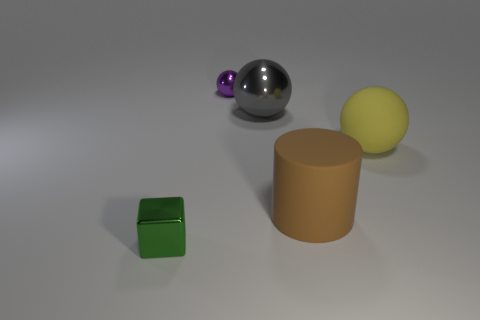How many other objects are the same material as the small purple ball?
Offer a very short reply. 2. How many small things are purple metal things or brown cylinders?
Make the answer very short. 1. Are there an equal number of large yellow rubber objects that are behind the gray metallic object and big things?
Your answer should be compact. No. There is a tiny metallic object that is in front of the purple ball; are there any gray things that are on the right side of it?
Give a very brief answer. Yes. What number of other things are there of the same color as the cube?
Your answer should be very brief. 0. What color is the big metallic ball?
Keep it short and to the point. Gray. There is a sphere that is both in front of the purple object and on the left side of the cylinder; what is its size?
Offer a very short reply. Large. How many objects are metallic objects that are behind the small cube or tiny green objects?
Provide a short and direct response. 3. What is the shape of the large brown thing that is made of the same material as the yellow object?
Offer a terse response. Cylinder. What is the shape of the large gray metal thing?
Provide a succinct answer. Sphere. 